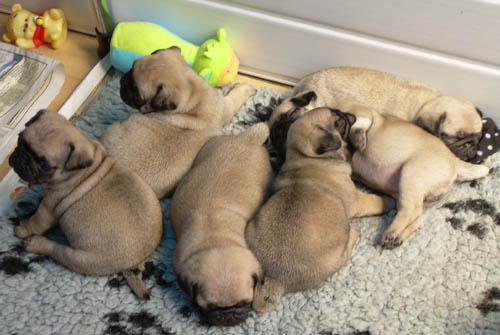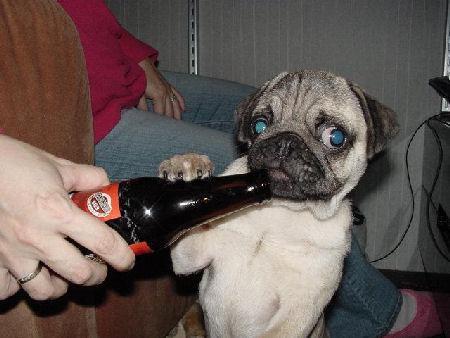The first image is the image on the left, the second image is the image on the right. Given the left and right images, does the statement "there are pugs with harnesses on" hold true? Answer yes or no. No. The first image is the image on the left, the second image is the image on the right. Considering the images on both sides, is "At least one dog is sleeping." valid? Answer yes or no. Yes. 